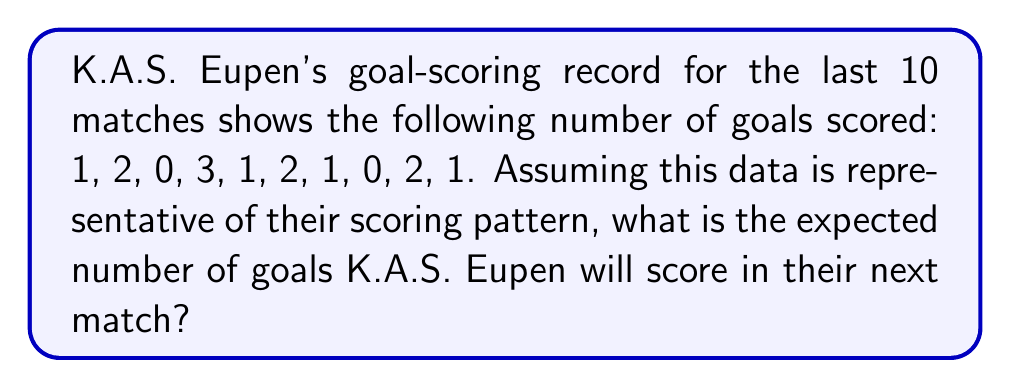Provide a solution to this math problem. To solve this problem, we need to calculate the expected value of the number of goals scored based on the given historical data. Here's how we can do it step-by-step:

1. List all the possible outcomes (number of goals scored) and their frequencies:
   0 goals: 2 times
   1 goal: 4 times
   2 goals: 3 times
   3 goals: 1 time

2. Calculate the probability of each outcome:
   $P(0) = \frac{2}{10} = 0.2$
   $P(1) = \frac{4}{10} = 0.4$
   $P(2) = \frac{3}{10} = 0.3$
   $P(3) = \frac{1}{10} = 0.1$

3. The expected value is calculated by multiplying each possible outcome by its probability and summing the results:

   $E(X) = \sum_{i=0}^{3} i \cdot P(i)$

   $E(X) = 0 \cdot 0.2 + 1 \cdot 0.4 + 2 \cdot 0.3 + 3 \cdot 0.1$

4. Compute the expected value:
   $E(X) = 0 + 0.4 + 0.6 + 0.3 = 1.3$

Therefore, based on the historical data, the expected number of goals K.A.S. Eupen will score in their next match is 1.3 goals.
Answer: 1.3 goals 